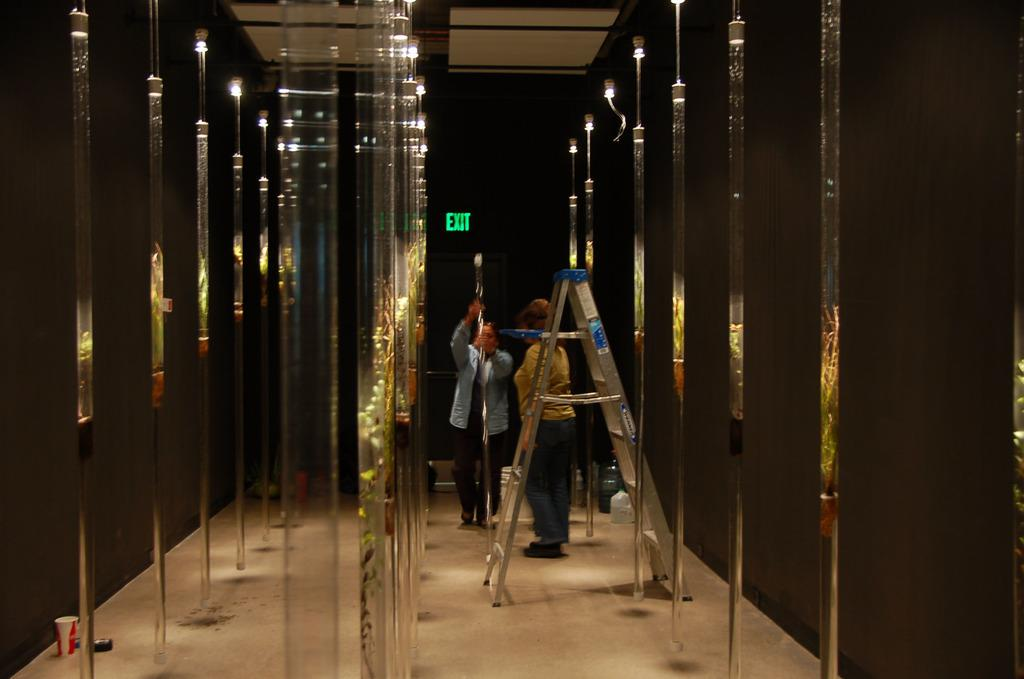<image>
Share a concise interpretation of the image provided. A green exit sign is behind two women. 